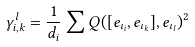Convert formula to latex. <formula><loc_0><loc_0><loc_500><loc_500>\gamma _ { i , k } ^ { l } = \frac { 1 } { d _ { i } } \sum Q ( [ e _ { \iota _ { i } } , e _ { \iota _ { k } } ] , e _ { \iota _ { l } } ) ^ { 2 }</formula> 